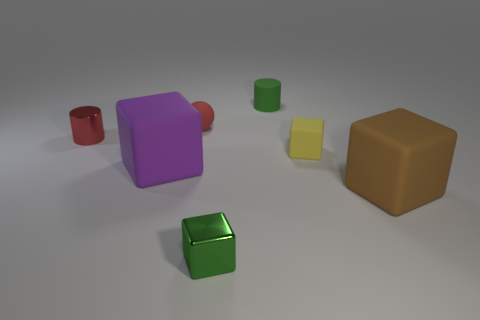There is a cube right of the small block that is to the right of the tiny cube in front of the purple cube; what size is it?
Your response must be concise. Large. There is a block to the left of the tiny thing in front of the tiny yellow cube; are there any small yellow blocks that are left of it?
Your response must be concise. No. Is the number of matte blocks greater than the number of green cubes?
Provide a succinct answer. Yes. What color is the big object on the left side of the yellow cube?
Your answer should be very brief. Purple. Is the number of big matte blocks that are on the right side of the tiny yellow rubber object greater than the number of cyan matte cylinders?
Offer a terse response. Yes. Is the material of the small yellow block the same as the small green cube?
Provide a succinct answer. No. How many other things are there of the same shape as the brown matte object?
Keep it short and to the point. 3. Are there any other things that are the same material as the brown cube?
Provide a succinct answer. Yes. What color is the big cube that is right of the big matte object that is to the left of the green matte object behind the red ball?
Your response must be concise. Brown. There is a small rubber object that is in front of the tiny red ball; is it the same shape as the large purple object?
Offer a very short reply. Yes. 